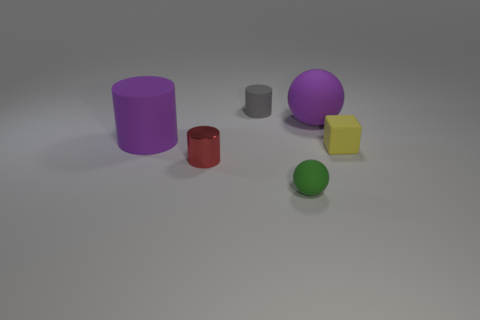What is the relative size of the purple object compared to the other objects? The purple sphere is relatively large compared to the other objects in the image, being the second-largest item after the violet cylinder. 